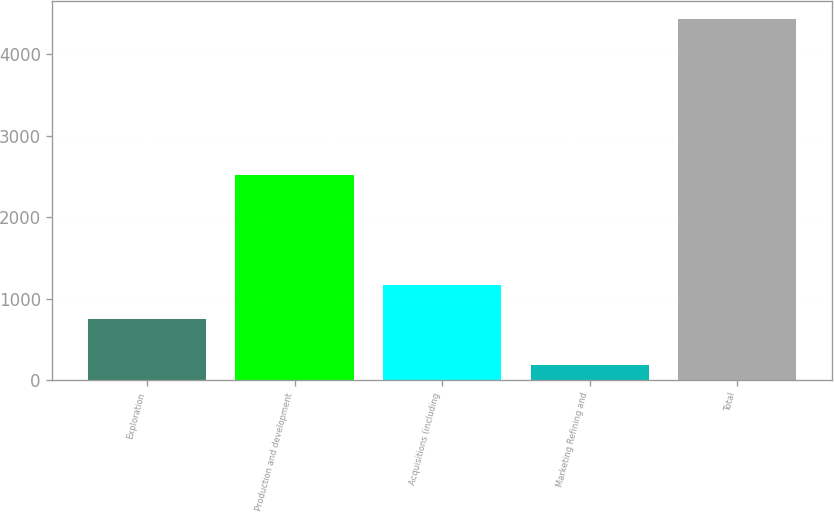<chart> <loc_0><loc_0><loc_500><loc_500><bar_chart><fcel>Exploration<fcel>Production and development<fcel>Acquisitions (including<fcel>Marketing Refining and<fcel>Total<nl><fcel>744<fcel>2523<fcel>1169.1<fcel>187<fcel>4438<nl></chart> 